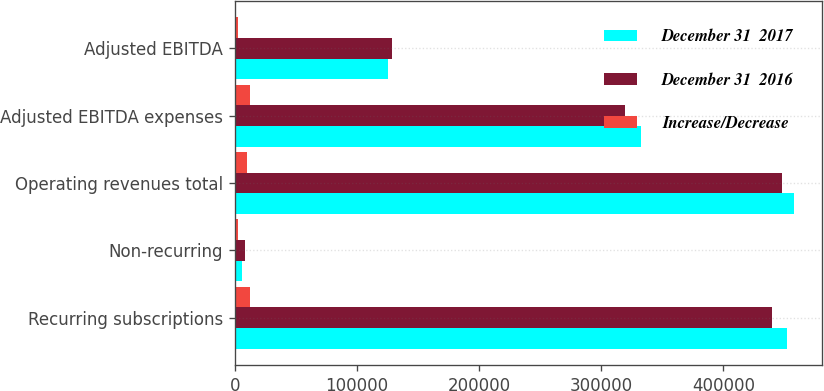Convert chart. <chart><loc_0><loc_0><loc_500><loc_500><stacked_bar_chart><ecel><fcel>Recurring subscriptions<fcel>Non-recurring<fcel>Operating revenues total<fcel>Adjusted EBITDA expenses<fcel>Adjusted EBITDA<nl><fcel>December 31  2017<fcel>452253<fcel>6016<fcel>458269<fcel>332645<fcel>125624<nl><fcel>December 31  2016<fcel>439864<fcel>8489<fcel>448353<fcel>319846<fcel>128507<nl><fcel>Increase/Decrease<fcel>12389<fcel>2473<fcel>9916<fcel>12799<fcel>2883<nl></chart> 